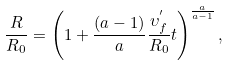<formula> <loc_0><loc_0><loc_500><loc_500>\frac { R } { R _ { 0 } } = \left ( 1 + \frac { ( a - 1 ) } { a } \frac { \upsilon _ { f } ^ { ^ { \prime } } } { R _ { 0 } } t \right ) ^ { \frac { a } { a - 1 } } ,</formula> 